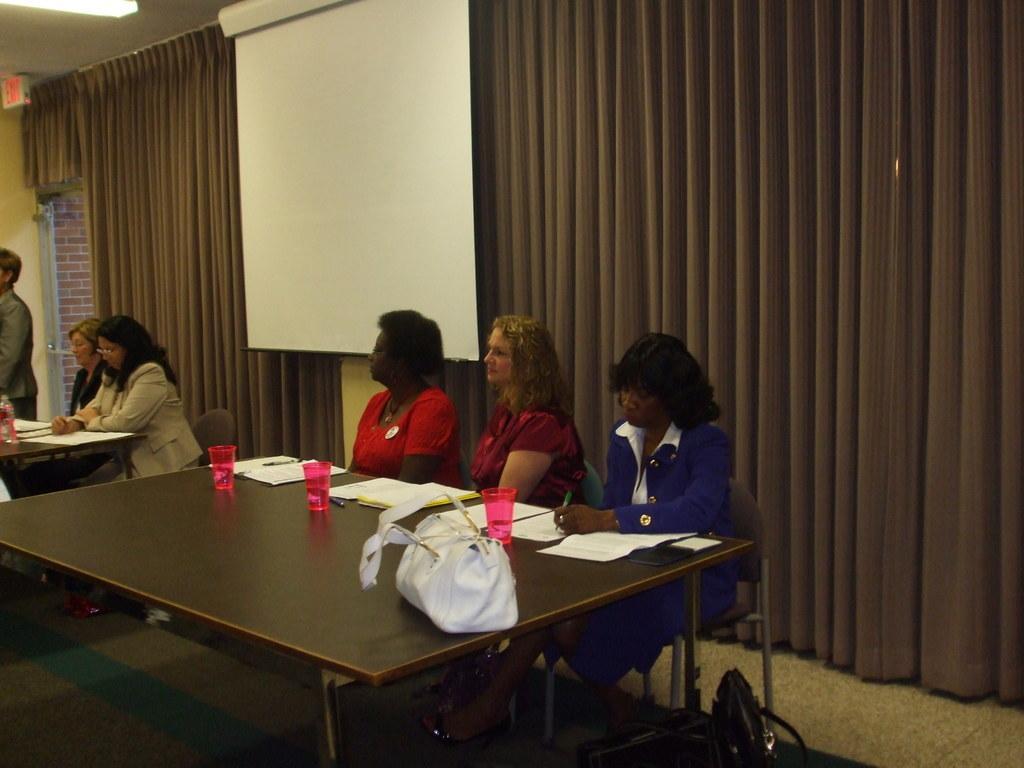In one or two sentences, can you explain what this image depicts? In this image there are three woman who are sitting in a chair and their is a table in front of them. On the table there are handbag,papers,cups. Beside these women there are another two woman who are sitting in chair and writing on the paper which is kept on table. At the back side there is a curtain and a projector. 